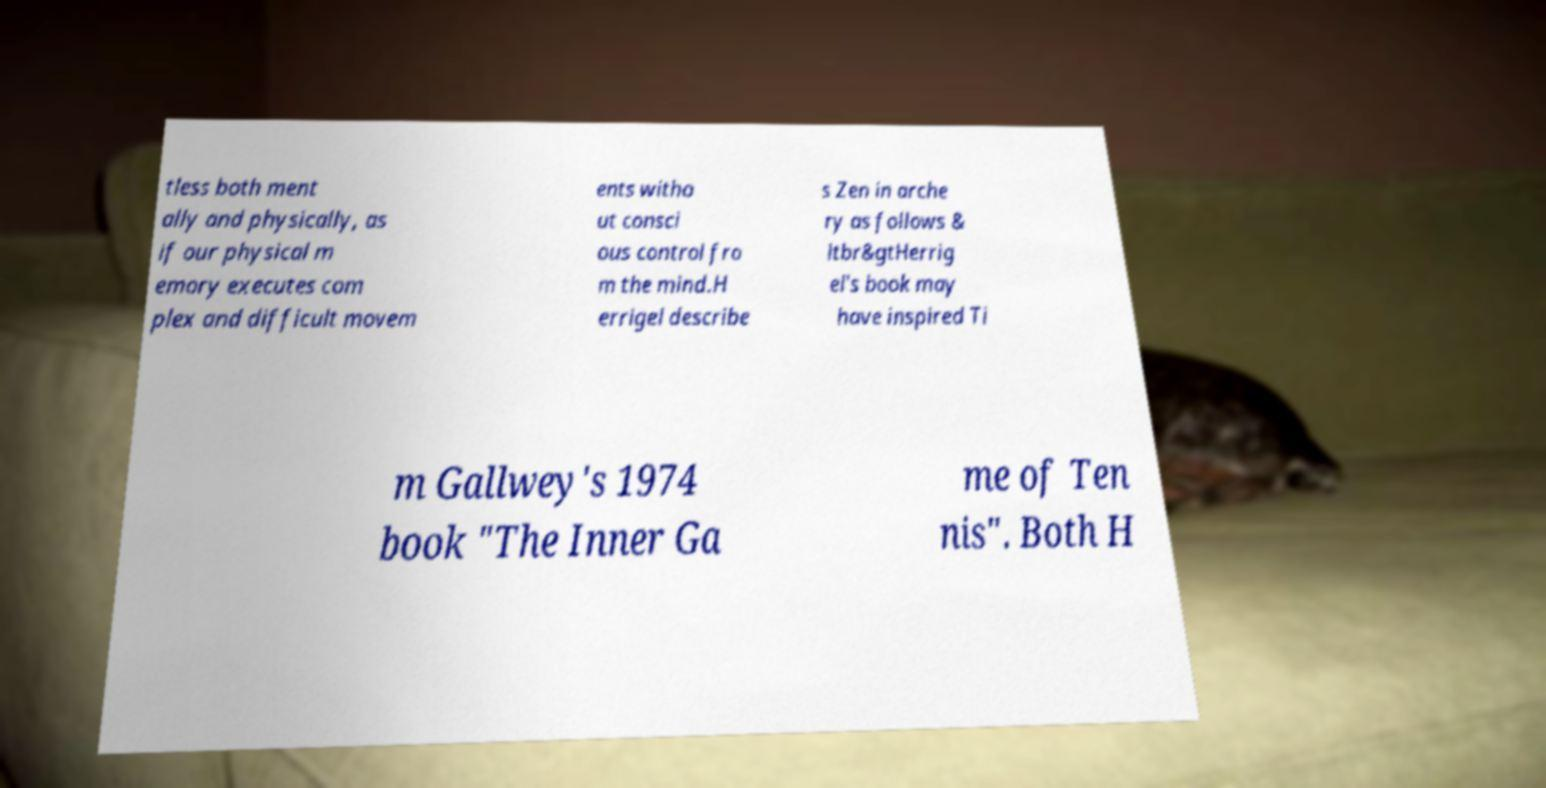There's text embedded in this image that I need extracted. Can you transcribe it verbatim? tless both ment ally and physically, as if our physical m emory executes com plex and difficult movem ents witho ut consci ous control fro m the mind.H errigel describe s Zen in arche ry as follows & ltbr&gtHerrig el's book may have inspired Ti m Gallwey's 1974 book "The Inner Ga me of Ten nis". Both H 